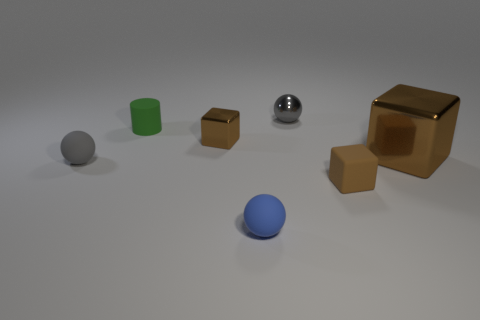Add 2 tiny green metal things. How many objects exist? 9 Subtract all cylinders. How many objects are left? 6 Subtract all tiny rubber blocks. Subtract all red shiny cubes. How many objects are left? 6 Add 7 large brown blocks. How many large brown blocks are left? 8 Add 3 big blue matte cubes. How many big blue matte cubes exist? 3 Subtract 0 blue blocks. How many objects are left? 7 